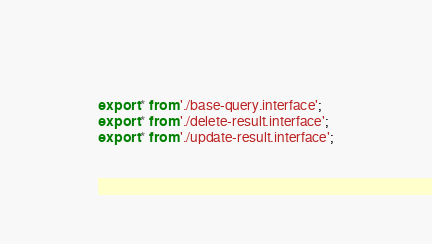<code> <loc_0><loc_0><loc_500><loc_500><_TypeScript_>export * from './base-query.interface';
export * from './delete-result.interface';
export * from './update-result.interface';
</code> 